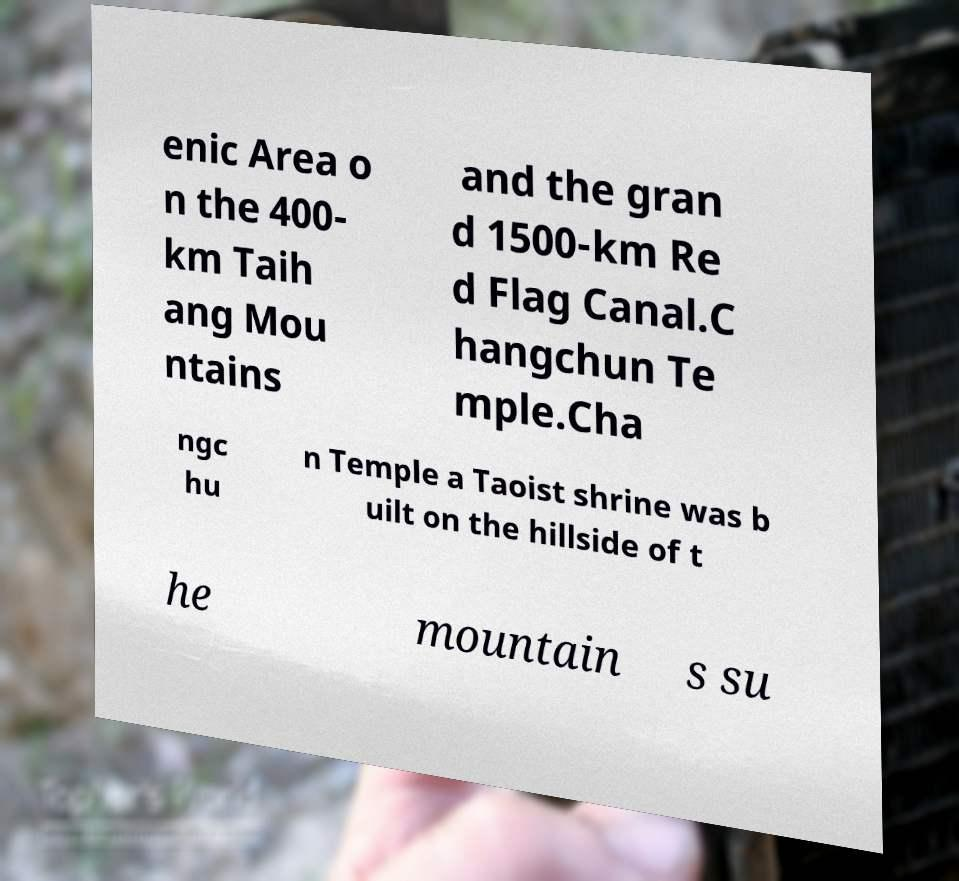Can you accurately transcribe the text from the provided image for me? enic Area o n the 400- km Taih ang Mou ntains and the gran d 1500-km Re d Flag Canal.C hangchun Te mple.Cha ngc hu n Temple a Taoist shrine was b uilt on the hillside of t he mountain s su 